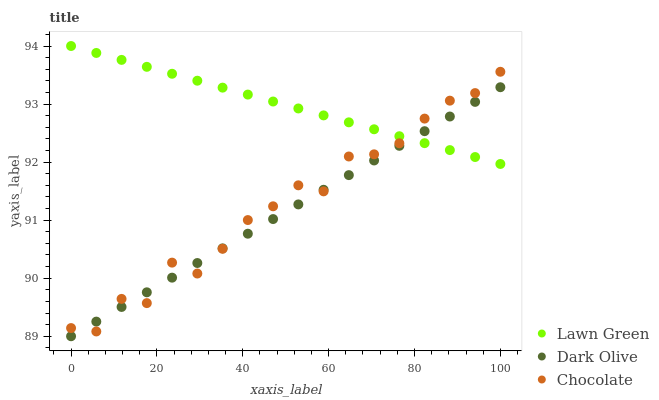Does Dark Olive have the minimum area under the curve?
Answer yes or no. Yes. Does Lawn Green have the maximum area under the curve?
Answer yes or no. Yes. Does Chocolate have the minimum area under the curve?
Answer yes or no. No. Does Chocolate have the maximum area under the curve?
Answer yes or no. No. Is Dark Olive the smoothest?
Answer yes or no. Yes. Is Chocolate the roughest?
Answer yes or no. Yes. Is Chocolate the smoothest?
Answer yes or no. No. Is Dark Olive the roughest?
Answer yes or no. No. Does Dark Olive have the lowest value?
Answer yes or no. Yes. Does Chocolate have the lowest value?
Answer yes or no. No. Does Lawn Green have the highest value?
Answer yes or no. Yes. Does Chocolate have the highest value?
Answer yes or no. No. Does Chocolate intersect Dark Olive?
Answer yes or no. Yes. Is Chocolate less than Dark Olive?
Answer yes or no. No. Is Chocolate greater than Dark Olive?
Answer yes or no. No. 